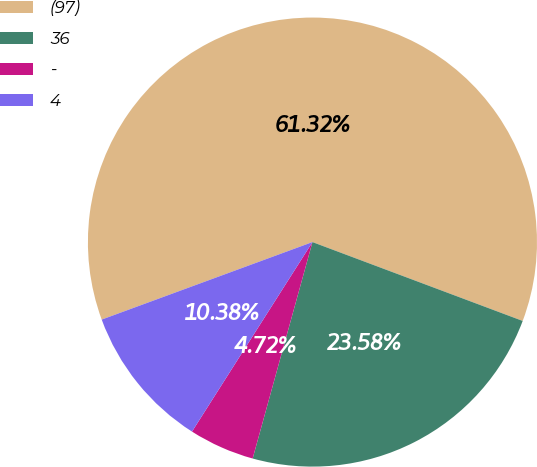Convert chart to OTSL. <chart><loc_0><loc_0><loc_500><loc_500><pie_chart><fcel>(97)<fcel>36<fcel>-<fcel>4<nl><fcel>61.32%<fcel>23.58%<fcel>4.72%<fcel>10.38%<nl></chart> 